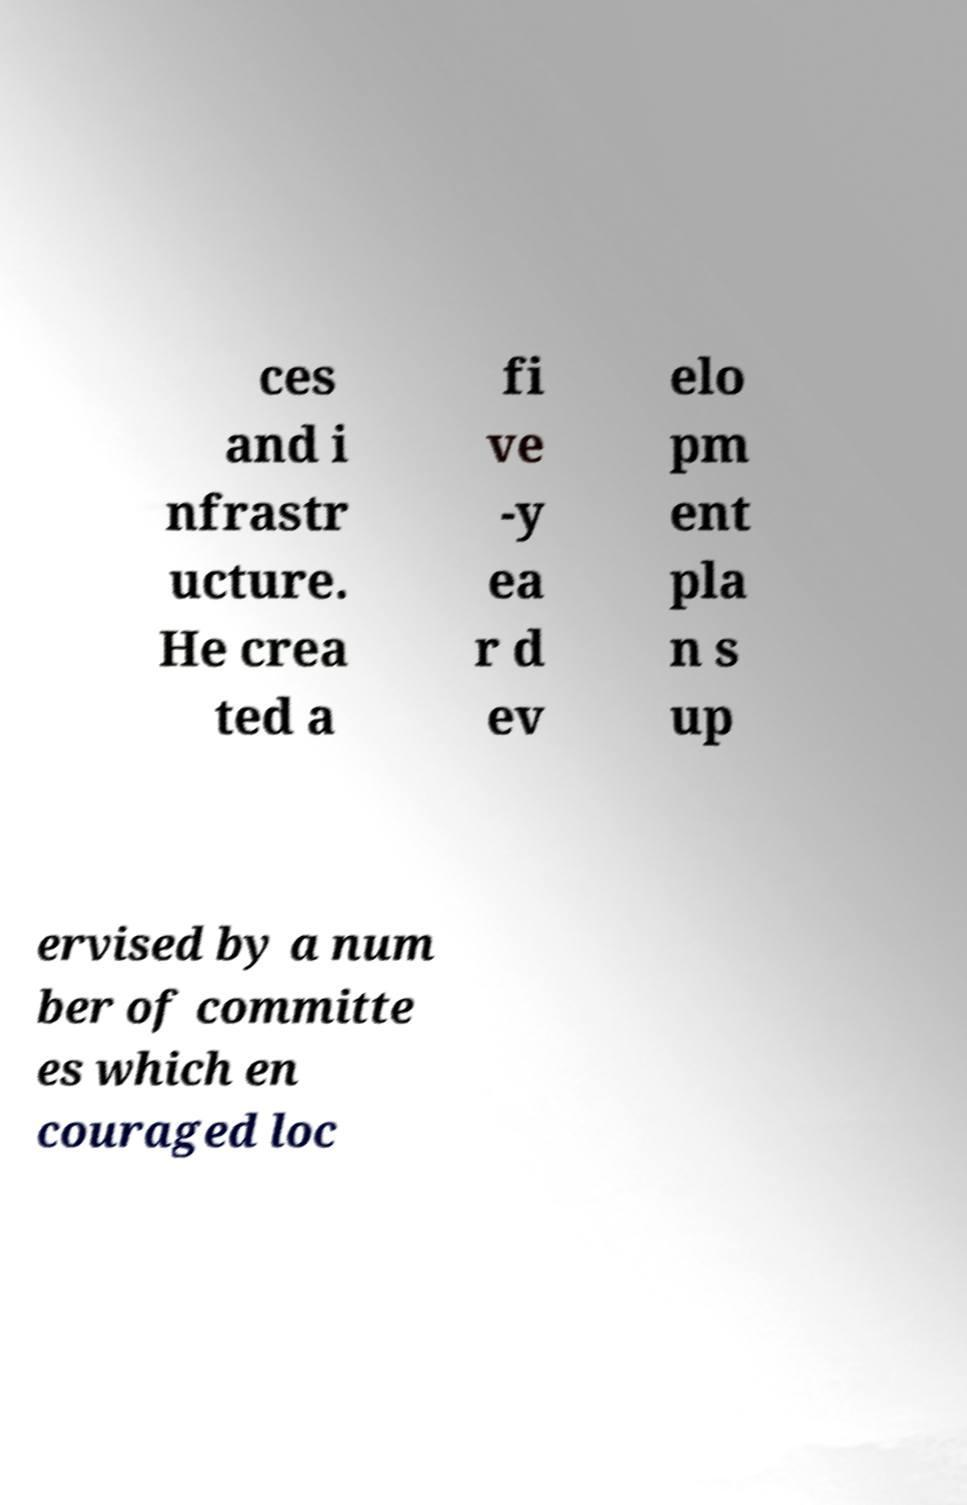Please read and relay the text visible in this image. What does it say? ces and i nfrastr ucture. He crea ted a fi ve -y ea r d ev elo pm ent pla n s up ervised by a num ber of committe es which en couraged loc 